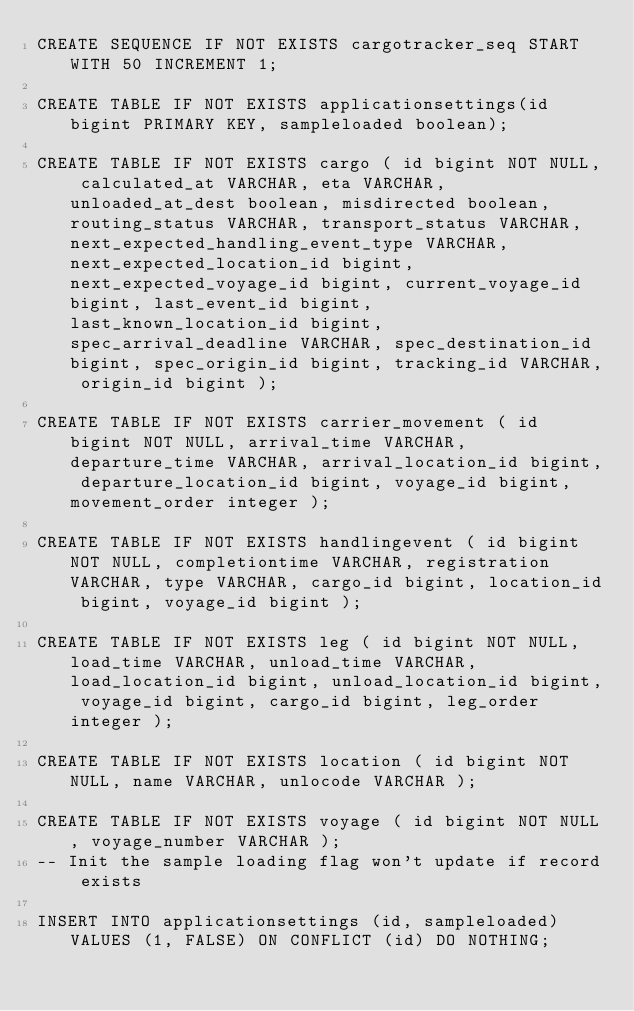Convert code to text. <code><loc_0><loc_0><loc_500><loc_500><_SQL_>CREATE SEQUENCE IF NOT EXISTS cargotracker_seq START WITH 50 INCREMENT 1;

CREATE TABLE IF NOT EXISTS applicationsettings(id bigint PRIMARY KEY, sampleloaded boolean);

CREATE TABLE IF NOT EXISTS cargo ( id bigint NOT NULL, calculated_at VARCHAR, eta VARCHAR, unloaded_at_dest boolean, misdirected boolean, routing_status VARCHAR, transport_status VARCHAR, next_expected_handling_event_type VARCHAR, next_expected_location_id bigint, next_expected_voyage_id bigint, current_voyage_id bigint, last_event_id bigint, last_known_location_id bigint, spec_arrival_deadline VARCHAR, spec_destination_id bigint, spec_origin_id bigint, tracking_id VARCHAR, origin_id bigint );

CREATE TABLE IF NOT EXISTS carrier_movement ( id bigint NOT NULL, arrival_time VARCHAR, departure_time VARCHAR, arrival_location_id bigint, departure_location_id bigint, voyage_id bigint, movement_order integer );

CREATE TABLE IF NOT EXISTS handlingevent ( id bigint NOT NULL, completiontime VARCHAR, registration VARCHAR, type VARCHAR, cargo_id bigint, location_id bigint, voyage_id bigint );

CREATE TABLE IF NOT EXISTS leg ( id bigint NOT NULL, load_time VARCHAR, unload_time VARCHAR, load_location_id bigint, unload_location_id bigint, voyage_id bigint, cargo_id bigint, leg_order integer );

CREATE TABLE IF NOT EXISTS location ( id bigint NOT NULL, name VARCHAR, unlocode VARCHAR );

CREATE TABLE IF NOT EXISTS voyage ( id bigint NOT NULL, voyage_number VARCHAR );
-- Init the sample loading flag won't update if record exists

INSERT INTO applicationsettings (id, sampleloaded) VALUES (1, FALSE) ON CONFLICT (id) DO NOTHING;
</code> 